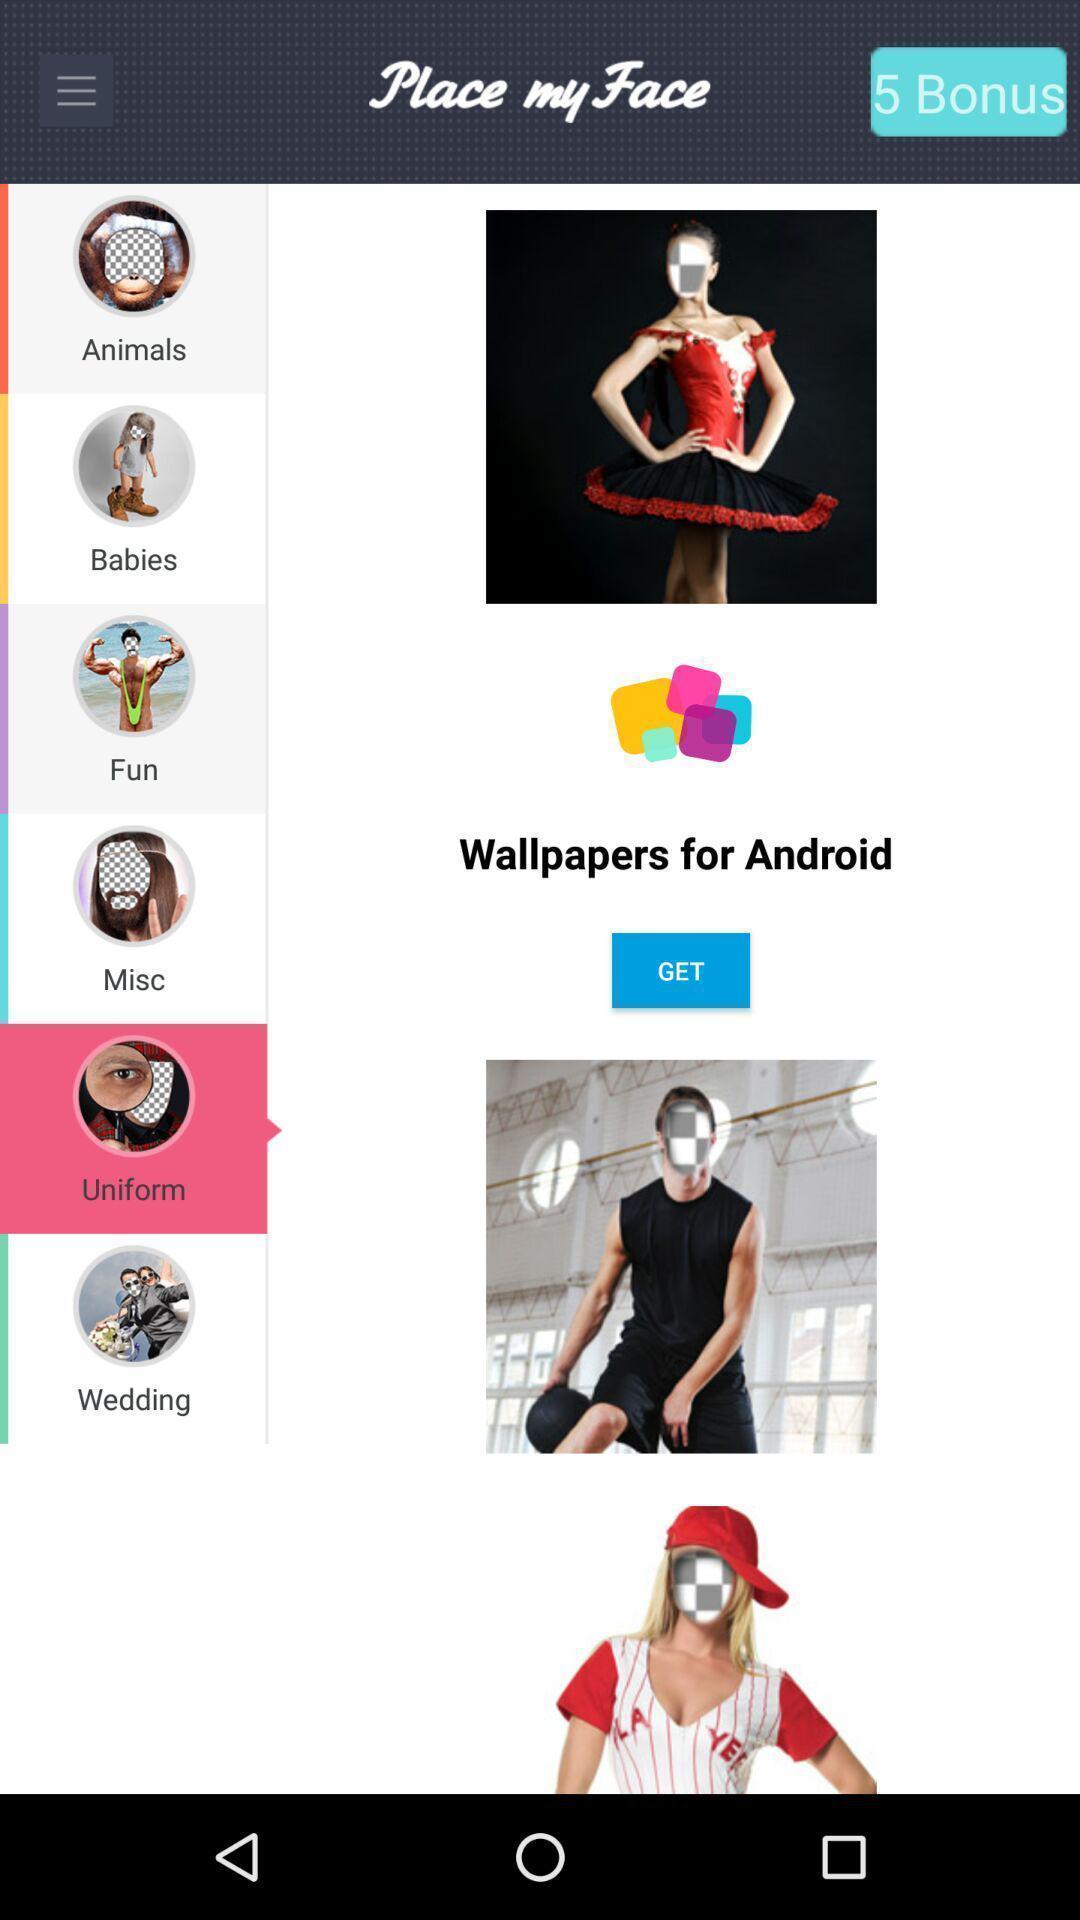What can you discern from this picture? Screen displaying multiple options in an image editing application. 